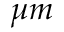<formula> <loc_0><loc_0><loc_500><loc_500>\mu m</formula> 